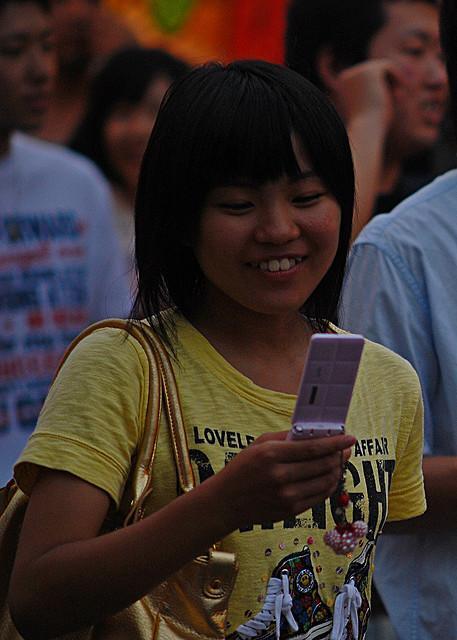How many people can be seen?
Give a very brief answer. 5. 